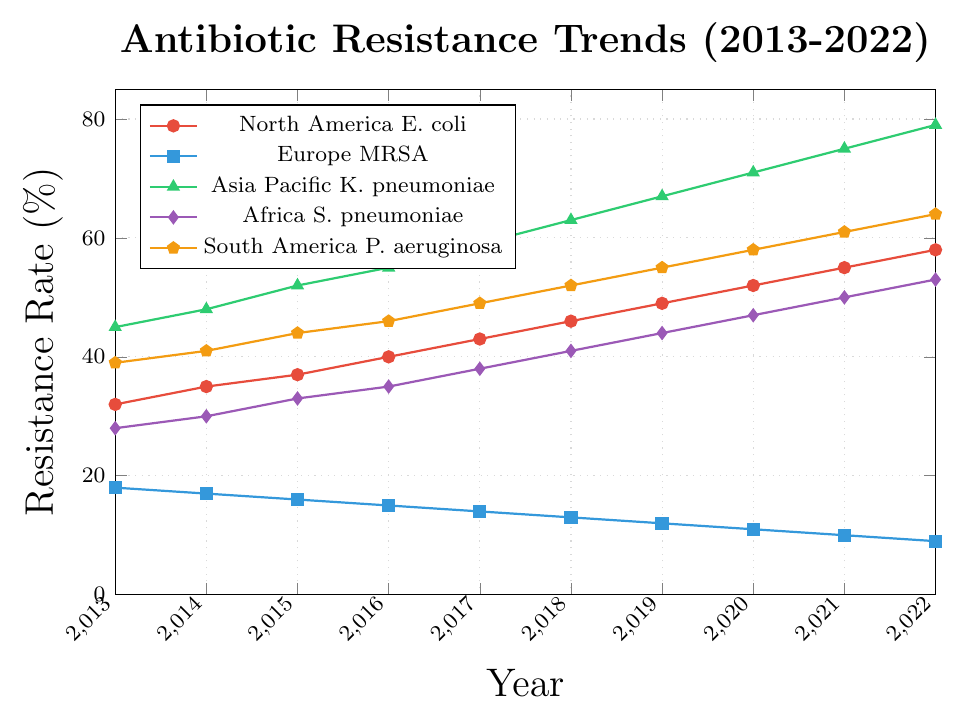Which region shows the highest increase in antibiotic resistance over the past decade? To find the region with the highest increase in antibiotic resistance, calculate the difference in resistance rates from 2013 to 2022 for each region: North America E. coli (58-32 = 26\%), Europe MRSA (9-18 = -9\%), Asia Pacific K. pneumoniae (79-45 = 34\%), Africa S. pneumoniae (53-28 = 25\%), South America P. aeruginosa (64-39 = 25\%). Asia Pacific K. pneumoniae has the highest increase.
Answer: Asia Pacific K. pneumoniae Which bacteria has shown a steady decline in antibiotic resistance in Europe? Observe the trend of Europe MRSA from 2013 to 2022: 18\%, 17\%, 16\%, 15\%, 14\%, 13\%, 12\%, 11\%, 10\%, 9\%. The antibiotic resistance of MRSA in Europe has been steadily declining over the past decade.
Answer: Europe MRSA What is the average resistance rate of South America P. aeruginosa over the past decade? Add up the resistance rates from 2013 to 2022: 39 + 41 + 44 + 46 + 49 + 52 + 55 + 58 + 61 + 64 = 509. Then divide by the number of years (10): 509/10 = 50.9\%.
Answer: 50.9\% How does the rate of resistance for North America E. coli in 2017 compare to Africa S. pneumoniae in the same year? Refer to the figure for 2017: North America E. coli is at 43\% and Africa S. pneumoniae is at 38\%. Comparatively, North America E. coli has a higher resistance rate than Africa S. pneumoniae in 2017.
Answer: North America E. coli is higher By how much did the resistance rate of Asia Pacific K. pneumoniae change from 2016 to 2018? Subtract the resistance rate in 2016 from that in 2018: 63\% - 55\% = 8\%. The resistance rate for Asia Pacific K. pneumoniae increased by 8\% from 2016 to 2018.
Answer: 8\% Among the regions shown, which one had the lowest antibiotic resistance rate in 2022? Check the resistance rates for 2022: North America E. coli (58\%), Europe MRSA (9\%), Asia Pacific K. pneumoniae (79\%), Africa S. pneumoniae (53\%), South America P. aeruginosa (64\%). Europe MRSA has the lowest resistance rate in 2022.
Answer: Europe MRSA What was the resistance rate trend for Africa S. pneumoniae over the decade? Look at the progression of resistance rates from 2013 to 2022 for Africa S. pneumoniae: 28\%, 30\%, 33\%, 35\%, 38\%, 41\%, 44\%, 47\%, 50\%, 53\%. The trend shows a continuous increase over the decade.
Answer: Continuous increase Calculate the decrease in resistance rate percentage for Europe MRSA from 2013 to 2022. The decrease can be calculated by subtracting the 2022 value from the 2013 value and then summarizing the change as a percentage: (18-9 = 9\%). The antibiotic resistance rate for Europe MRSA decreased by 9 percentage points from 2013 to 2022.
Answer: 9\% Which bacteria in which region showed the greatest resistance increase from 2019 to 2022? Evaluate the increase by subtracting the 2019 values from the 2022 values for each: North America E. coli (58-49 = 9\%), Europe MRSA (9-12 = -3\%), Asia Pacific K. pneumoniae (79-67 = 12\%), Africa S. pneumoniae (53-44 = 9\%), South America P. aeruginosa (64-55 = 9\%). Asia Pacific K. pneumoniae showed the greatest increase of 12 percentage points.
Answer: Asia Pacific K. pneumoniae 